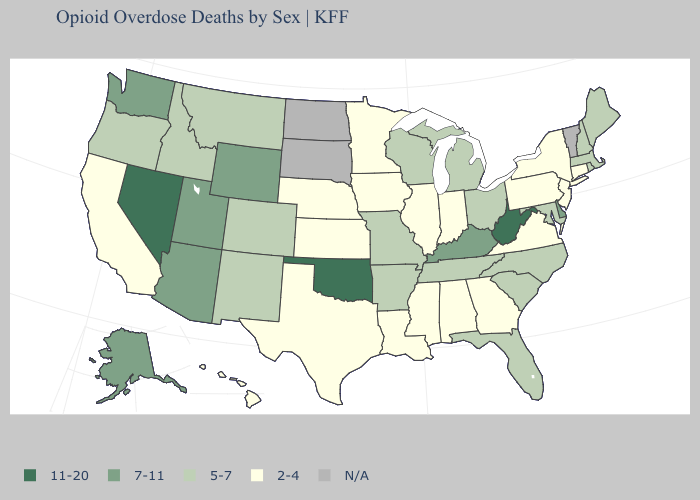What is the value of Massachusetts?
Concise answer only. 5-7. What is the lowest value in the Northeast?
Keep it brief. 2-4. What is the value of North Carolina?
Be succinct. 5-7. Name the states that have a value in the range N/A?
Be succinct. North Dakota, South Dakota, Vermont. Which states have the lowest value in the South?
Concise answer only. Alabama, Georgia, Louisiana, Mississippi, Texas, Virginia. What is the value of Indiana?
Short answer required. 2-4. Does Georgia have the lowest value in the South?
Give a very brief answer. Yes. Among the states that border Colorado , which have the lowest value?
Give a very brief answer. Kansas, Nebraska. What is the value of Alabama?
Concise answer only. 2-4. What is the highest value in the West ?
Write a very short answer. 11-20. Does the first symbol in the legend represent the smallest category?
Give a very brief answer. No. 